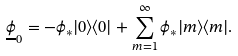Convert formula to latex. <formula><loc_0><loc_0><loc_500><loc_500>\underline { \phi } _ { 0 } = - \phi _ { * } | 0 \rangle \langle 0 | + \sum _ { m = 1 } ^ { \infty } \phi _ { * } | m \rangle \langle m | .</formula> 